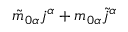Convert formula to latex. <formula><loc_0><loc_0><loc_500><loc_500>\tilde { m } _ { 0 \alpha } j ^ { \alpha } + m _ { 0 \alpha } \tilde { j } ^ { \alpha }</formula> 